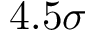<formula> <loc_0><loc_0><loc_500><loc_500>4 . 5 \sigma</formula> 